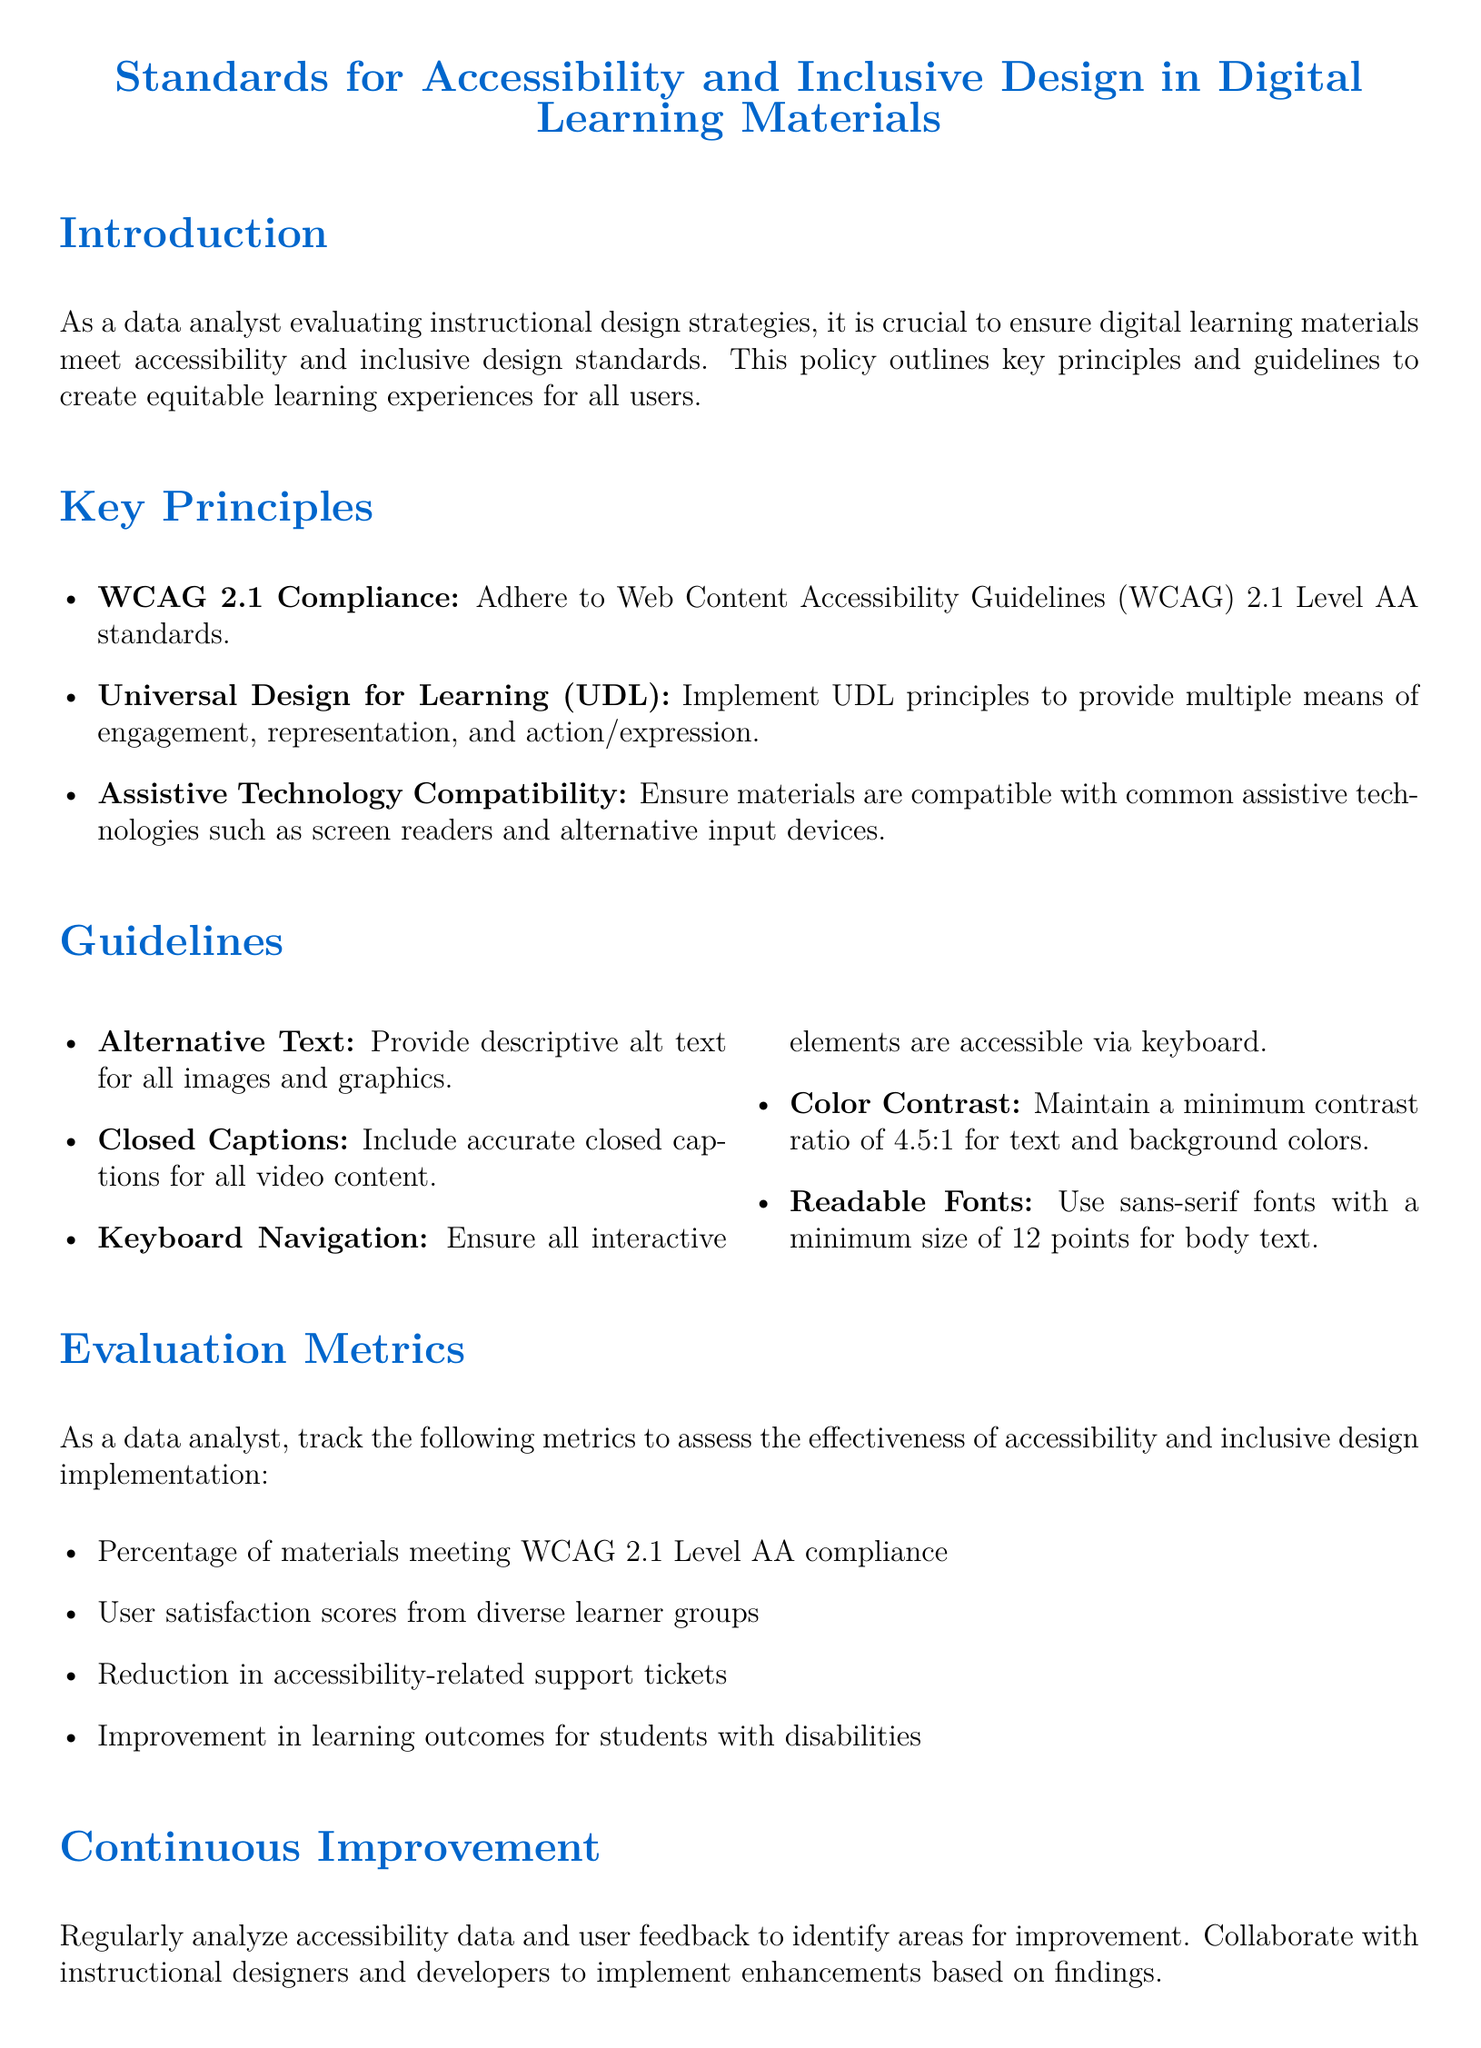What is the title of the document? The title is explicitly stated at the beginning of the document.
Answer: Standards for Accessibility and Inclusive Design in Digital Learning Materials What are the three key principles outlined in the document? The three key principles are mentioned in a list under the Key Principles section.
Answer: WCAG 2.1 Compliance, Universal Design for Learning (UDL), Assistive Technology Compatibility What is the minimum contrast ratio specified for text and background colors? The minimum contrast ratio is provided in the guidelines for color contrast.
Answer: 4.5:1 Which font type and size are recommended for body text? The recommended font type and size are listed in the guidelines section for readable fonts.
Answer: sans-serif fonts with a minimum size of 12 points What metric measures user satisfaction from diverse learner groups? User satisfaction scores from diverse learner groups are specified as a metric under Evaluation Metrics.
Answer: user satisfaction scores What should be analyzed regularly to identify areas for improvement? The document specifies a type of data that should be analyzed regularly for improvements.
Answer: accessibility data and user feedback What is the purpose of adhering to WCAG 2.1 standards? The purpose is explained in the context of creating equitable learning experiences.
Answer: to meet accessibility and inclusive design standards How often should accessibility data and user feedback be analyzed? The frequency is implied as part of the continuous improvement process described in the document.
Answer: regularly 